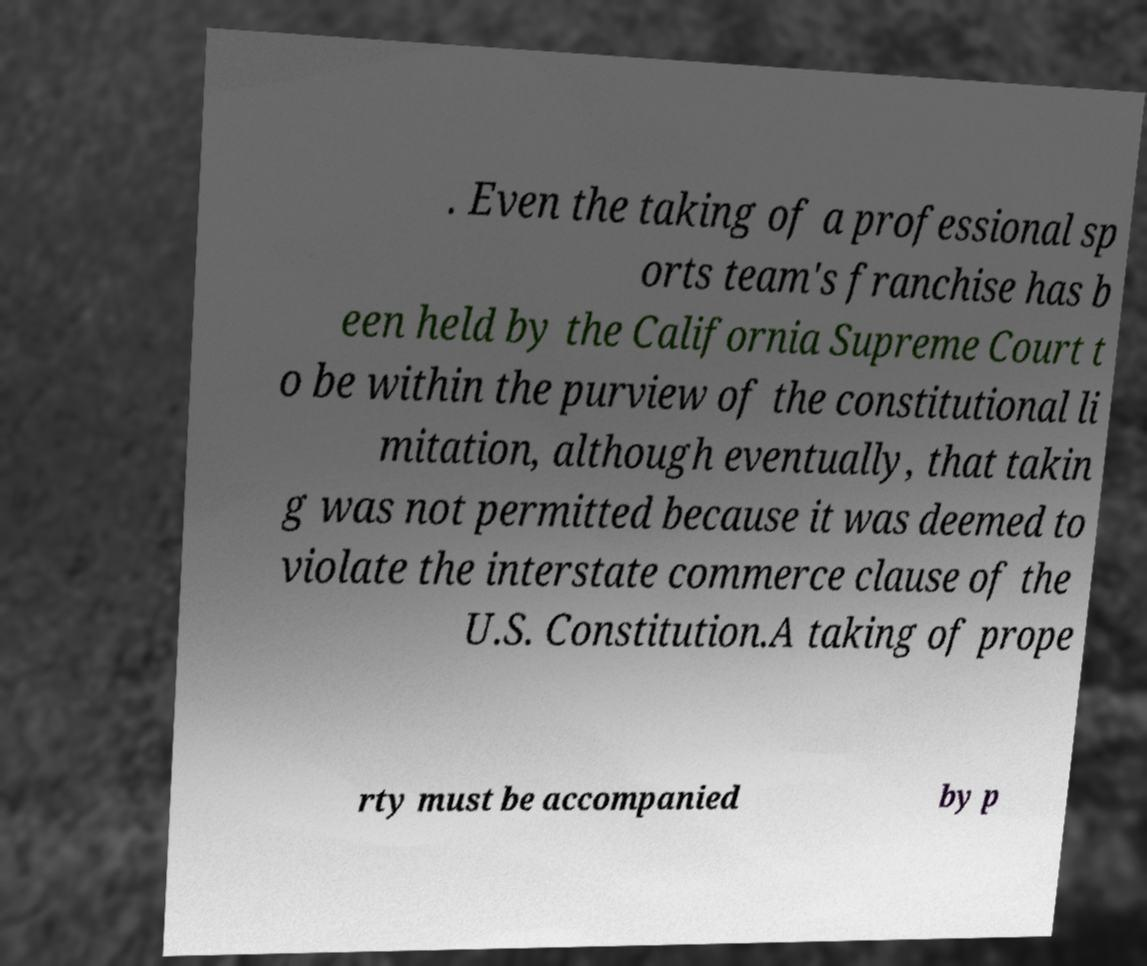Could you extract and type out the text from this image? . Even the taking of a professional sp orts team's franchise has b een held by the California Supreme Court t o be within the purview of the constitutional li mitation, although eventually, that takin g was not permitted because it was deemed to violate the interstate commerce clause of the U.S. Constitution.A taking of prope rty must be accompanied by p 